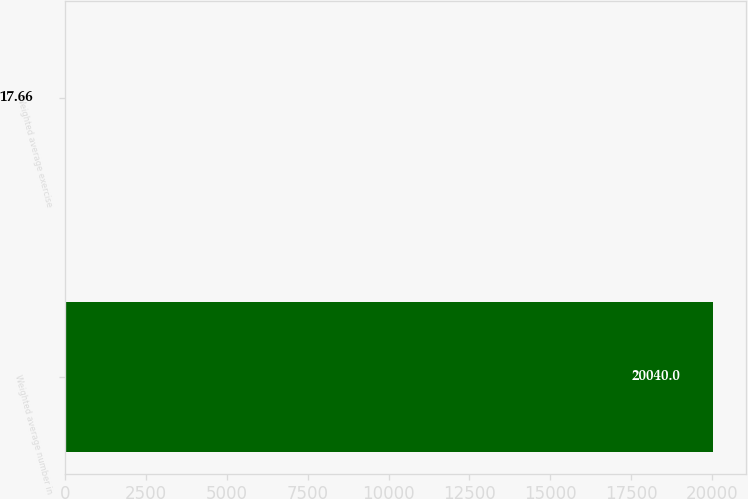<chart> <loc_0><loc_0><loc_500><loc_500><bar_chart><fcel>Weighted average number in<fcel>Weighted average exercise<nl><fcel>20040<fcel>17.66<nl></chart> 